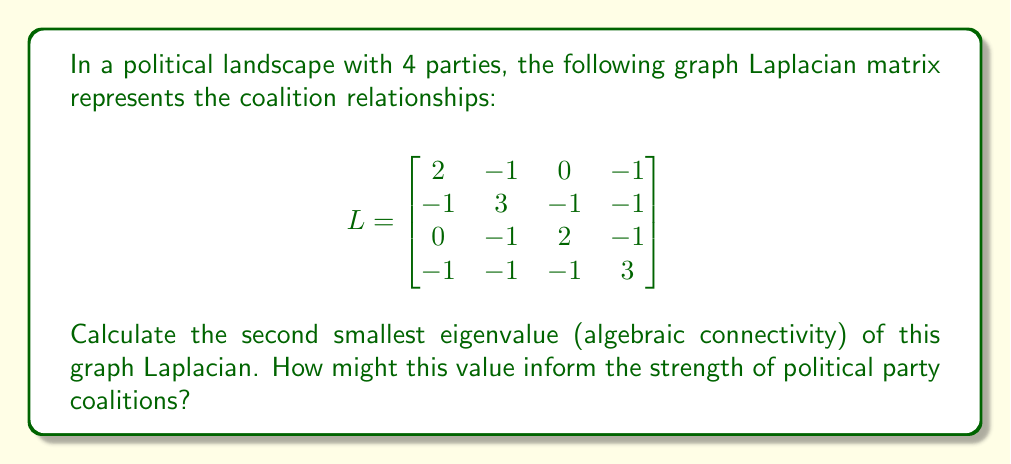Can you solve this math problem? To find the second smallest eigenvalue of the graph Laplacian, we'll follow these steps:

1) First, recall that for any graph Laplacian, the smallest eigenvalue is always 0. So we're looking for the second smallest.

2) To find the eigenvalues, we need to solve the characteristic equation:
   $$det(L - \lambda I) = 0$$

3) Expanding this determinant:
   $$\begin{vmatrix}
   2-\lambda & -1 & 0 & -1 \\
   -1 & 3-\lambda & -1 & -1 \\
   0 & -1 & 2-\lambda & -1 \\
   -1 & -1 & -1 & 3-\lambda
   \end{vmatrix} = 0$$

4) This expands to the characteristic polynomial:
   $$\lambda^4 - 10\lambda^3 + 31\lambda^2 - 30\lambda = 0$$

5) Factor out $\lambda$:
   $$\lambda(\lambda^3 - 10\lambda^2 + 31\lambda - 30) = 0$$

6) We know $\lambda = 0$ is one solution. For the other factor, we can use the rational root theorem or a computer algebra system to find the roots:
   $$\lambda = 0, 1, 4, 5$$

7) The second smallest eigenvalue is therefore 1.

Interpretation: The algebraic connectivity (second smallest eigenvalue) of 1 indicates a moderately connected graph. In political terms, this suggests that while there are some coalition relationships, they are not extremely strong. A higher value would indicate stronger, more interconnected coalitions, while a value closer to 0 would suggest weaker, more fragmented relationships between parties.
Answer: 1 